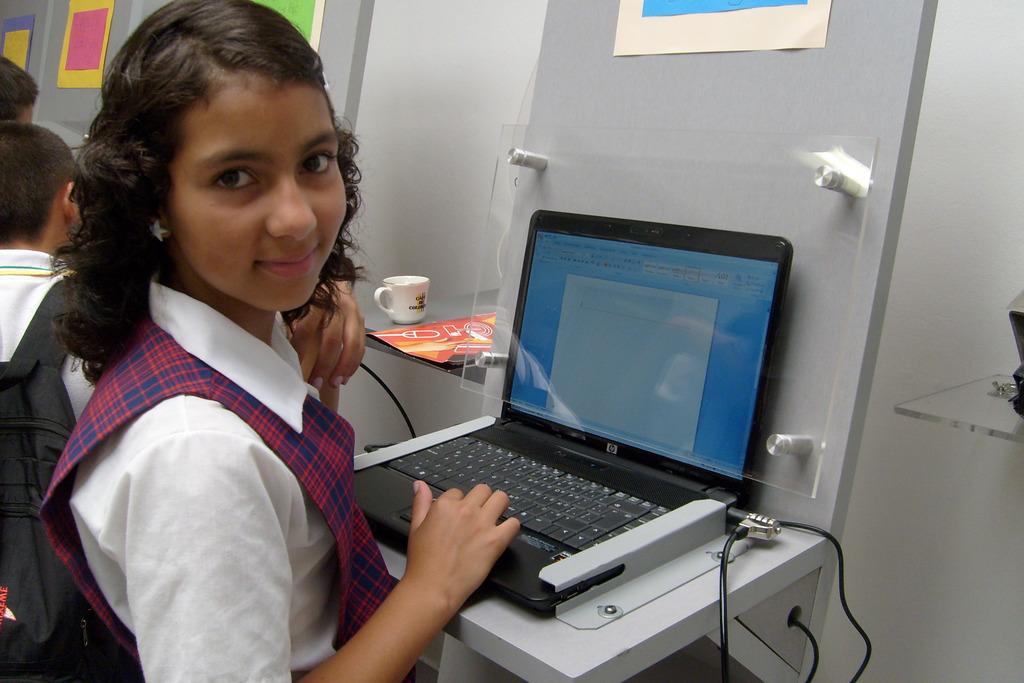What brand of laptop is this?
Your answer should be compact. Hp. 